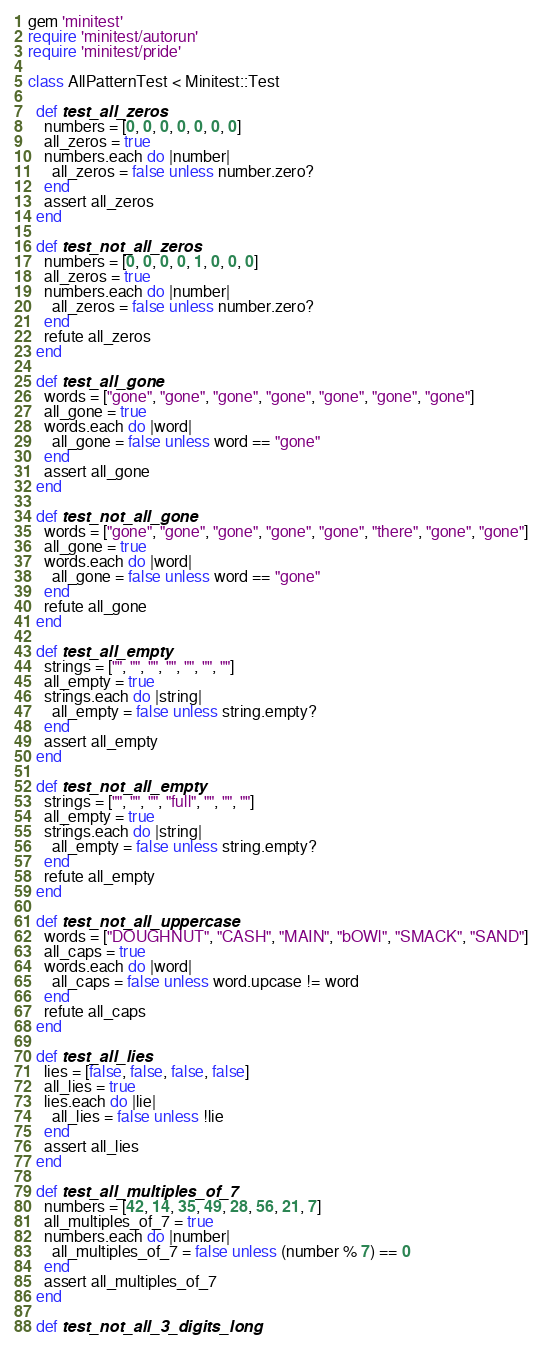Convert code to text. <code><loc_0><loc_0><loc_500><loc_500><_Ruby_>gem 'minitest'
require 'minitest/autorun'
require 'minitest/pride'

class AllPatternTest < Minitest::Test

  def test_all_zeros
    numbers = [0, 0, 0, 0, 0, 0, 0]
    all_zeros = true
    numbers.each do |number|
      all_zeros = false unless number.zero?
    end
    assert all_zeros
  end

  def test_not_all_zeros
    numbers = [0, 0, 0, 0, 1, 0, 0, 0]
    all_zeros = true
    numbers.each do |number|
      all_zeros = false unless number.zero?
    end
    refute all_zeros
  end

  def test_all_gone
    words = ["gone", "gone", "gone", "gone", "gone", "gone", "gone"]
    all_gone = true
    words.each do |word|
      all_gone = false unless word == "gone"
    end
    assert all_gone
  end

  def test_not_all_gone
    words = ["gone", "gone", "gone", "gone", "gone", "there", "gone", "gone"]
    all_gone = true
    words.each do |word|
      all_gone = false unless word == "gone"
    end
    refute all_gone
  end

  def test_all_empty
    strings = ["", "", "", "", "", "", ""]
    all_empty = true
    strings.each do |string|
      all_empty = false unless string.empty?
    end
    assert all_empty
  end

  def test_not_all_empty
    strings = ["", "", "", "full", "", "", ""]
    all_empty = true
    strings.each do |string|
      all_empty = false unless string.empty?
    end
    refute all_empty
  end

  def test_not_all_uppercase
    words = ["DOUGHNUT", "CASH", "MAIN", "bOWl", "SMACK", "SAND"]
    all_caps = true
    words.each do |word|
      all_caps = false unless word.upcase != word
    end
    refute all_caps
  end

  def test_all_lies
    lies = [false, false, false, false]
    all_lies = true
    lies.each do |lie|
      all_lies = false unless !lie
    end
    assert all_lies
  end

  def test_all_multiples_of_7
    numbers = [42, 14, 35, 49, 28, 56, 21, 7]
    all_multiples_of_7 = true
    numbers.each do |number|
      all_multiples_of_7 = false unless (number % 7) == 0
    end
    assert all_multiples_of_7
  end

  def test_not_all_3_digits_long</code> 